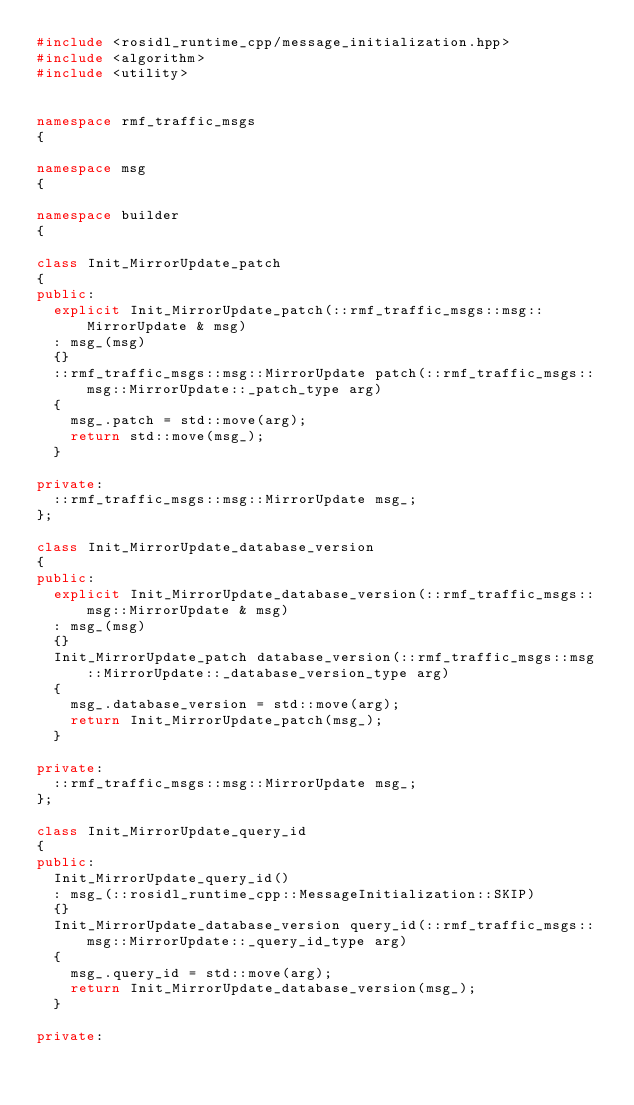Convert code to text. <code><loc_0><loc_0><loc_500><loc_500><_C++_>#include <rosidl_runtime_cpp/message_initialization.hpp>
#include <algorithm>
#include <utility>


namespace rmf_traffic_msgs
{

namespace msg
{

namespace builder
{

class Init_MirrorUpdate_patch
{
public:
  explicit Init_MirrorUpdate_patch(::rmf_traffic_msgs::msg::MirrorUpdate & msg)
  : msg_(msg)
  {}
  ::rmf_traffic_msgs::msg::MirrorUpdate patch(::rmf_traffic_msgs::msg::MirrorUpdate::_patch_type arg)
  {
    msg_.patch = std::move(arg);
    return std::move(msg_);
  }

private:
  ::rmf_traffic_msgs::msg::MirrorUpdate msg_;
};

class Init_MirrorUpdate_database_version
{
public:
  explicit Init_MirrorUpdate_database_version(::rmf_traffic_msgs::msg::MirrorUpdate & msg)
  : msg_(msg)
  {}
  Init_MirrorUpdate_patch database_version(::rmf_traffic_msgs::msg::MirrorUpdate::_database_version_type arg)
  {
    msg_.database_version = std::move(arg);
    return Init_MirrorUpdate_patch(msg_);
  }

private:
  ::rmf_traffic_msgs::msg::MirrorUpdate msg_;
};

class Init_MirrorUpdate_query_id
{
public:
  Init_MirrorUpdate_query_id()
  : msg_(::rosidl_runtime_cpp::MessageInitialization::SKIP)
  {}
  Init_MirrorUpdate_database_version query_id(::rmf_traffic_msgs::msg::MirrorUpdate::_query_id_type arg)
  {
    msg_.query_id = std::move(arg);
    return Init_MirrorUpdate_database_version(msg_);
  }

private:</code> 